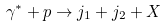Convert formula to latex. <formula><loc_0><loc_0><loc_500><loc_500>\gamma ^ { * } + p \rightarrow j _ { 1 } + j _ { 2 } + X</formula> 